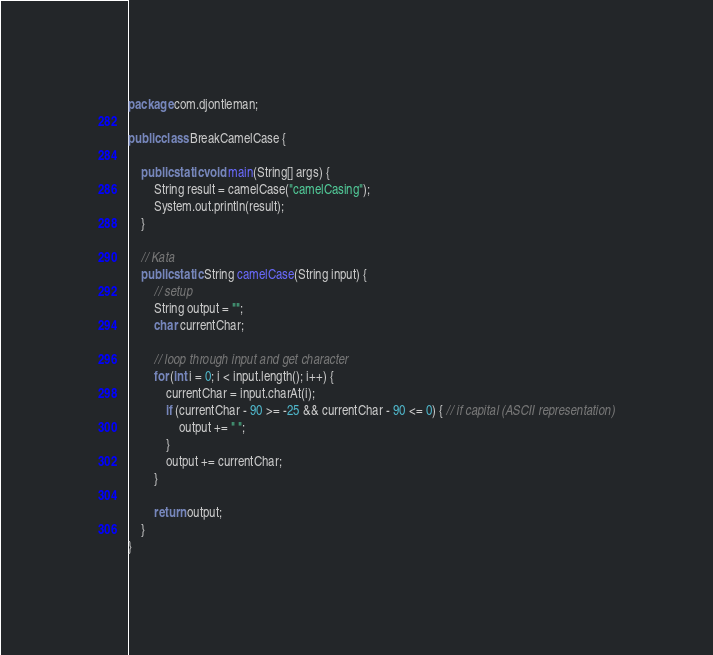Convert code to text. <code><loc_0><loc_0><loc_500><loc_500><_Java_>package com.djontleman;

public class BreakCamelCase {

    public static void main(String[] args) {
        String result = camelCase("camelCasing");
        System.out.println(result);
    }

    // Kata
    public static String camelCase(String input) {
        // setup
        String output = "";
        char currentChar;

        // loop through input and get character
        for (int i = 0; i < input.length(); i++) {
            currentChar = input.charAt(i);
            if (currentChar - 90 >= -25 && currentChar - 90 <= 0) { // if capital (ASCII representation)
                output += " ";
            }
            output += currentChar;
        }

        return output;
    }
}
</code> 